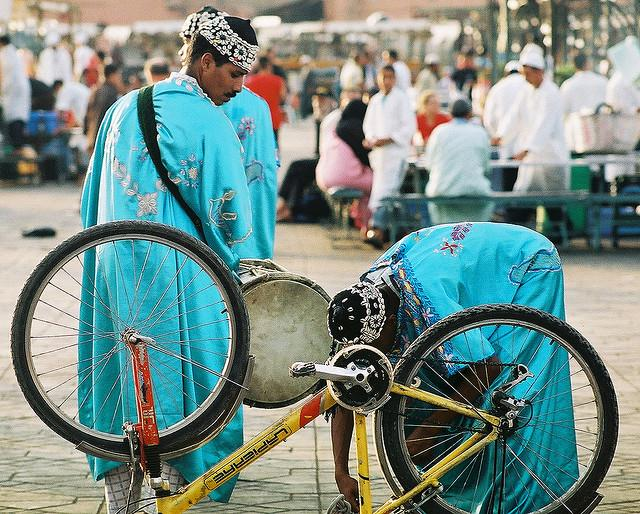What mode of transportation is upside-down? Please explain your reasoning. bicycle. They have turned it upside down to look at it and probably try to fix it. 